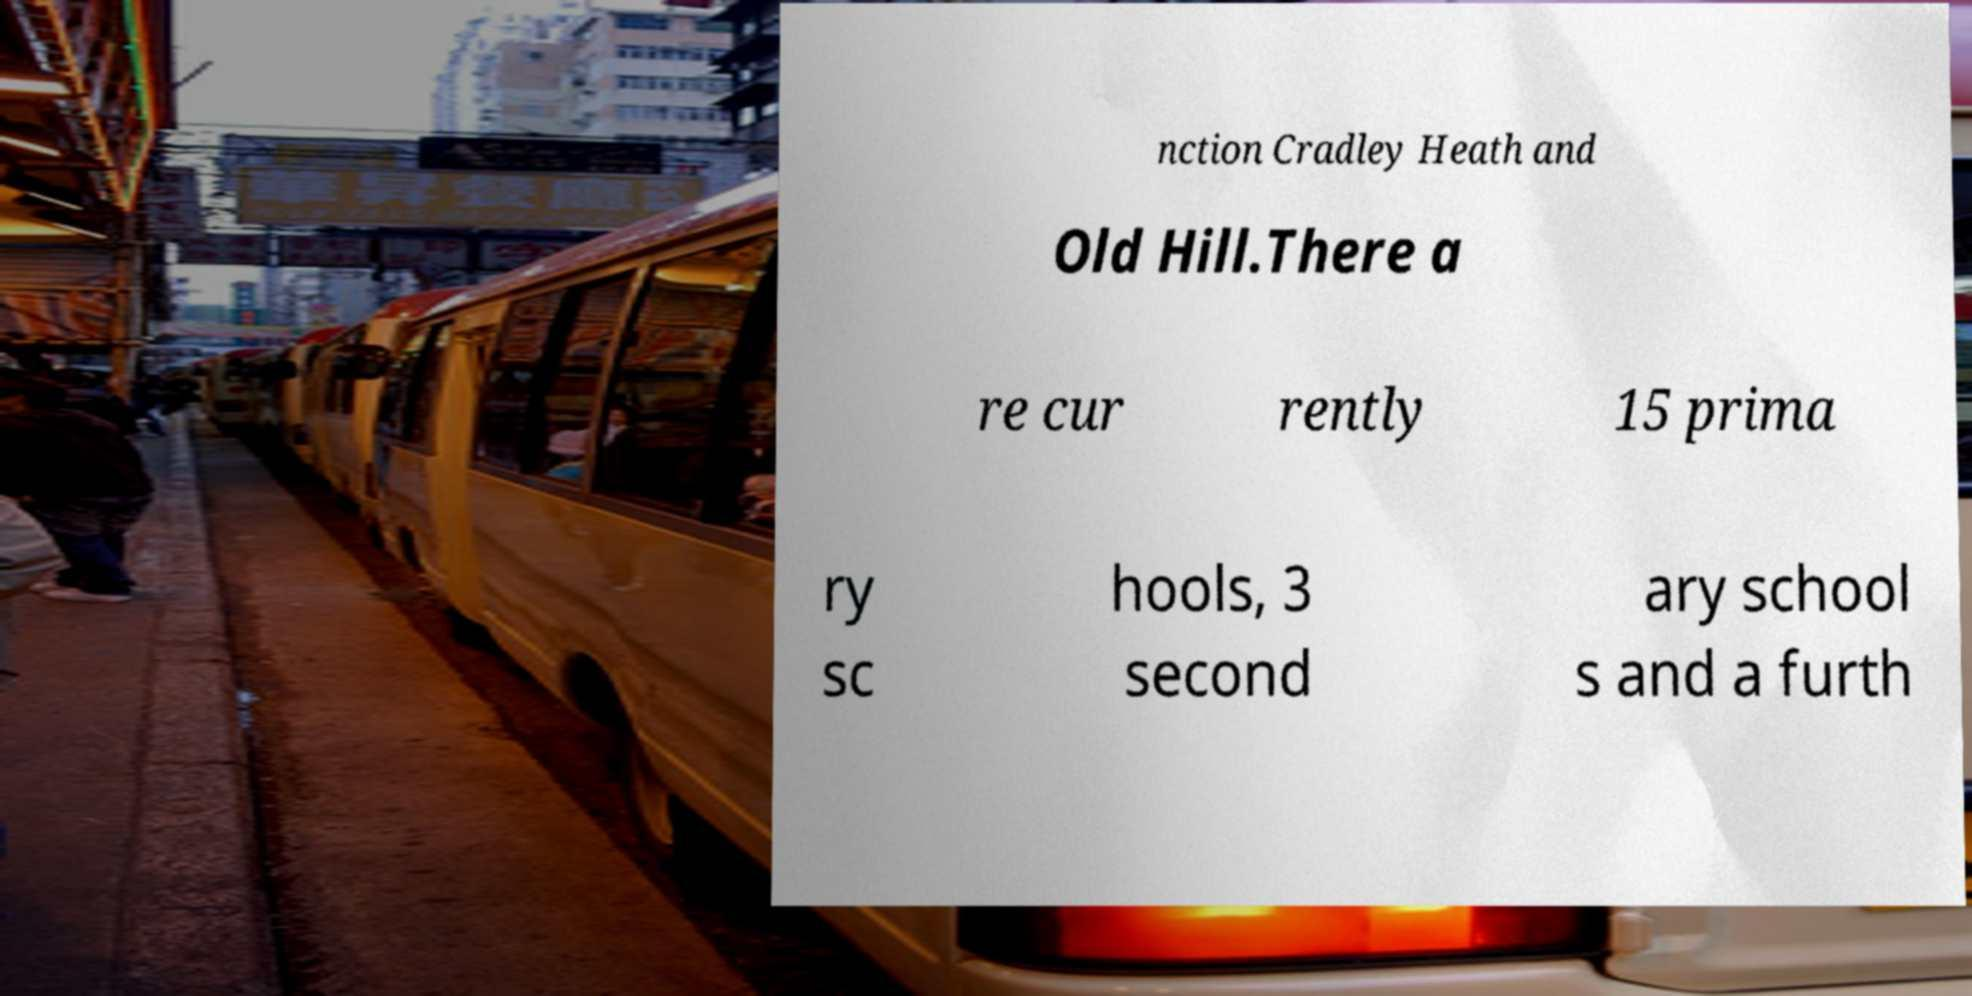Please read and relay the text visible in this image. What does it say? nction Cradley Heath and Old Hill.There a re cur rently 15 prima ry sc hools, 3 second ary school s and a furth 